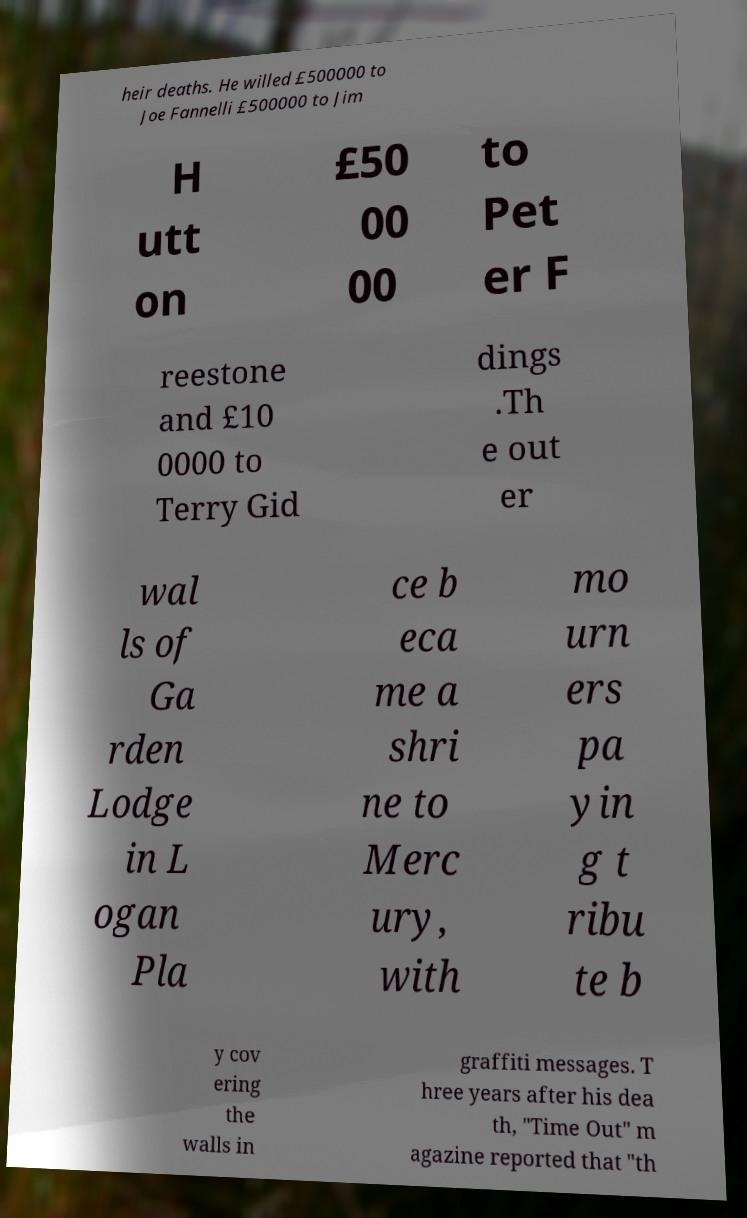Please identify and transcribe the text found in this image. heir deaths. He willed £500000 to Joe Fannelli £500000 to Jim H utt on £50 00 00 to Pet er F reestone and £10 0000 to Terry Gid dings .Th e out er wal ls of Ga rden Lodge in L ogan Pla ce b eca me a shri ne to Merc ury, with mo urn ers pa yin g t ribu te b y cov ering the walls in graffiti messages. T hree years after his dea th, "Time Out" m agazine reported that "th 